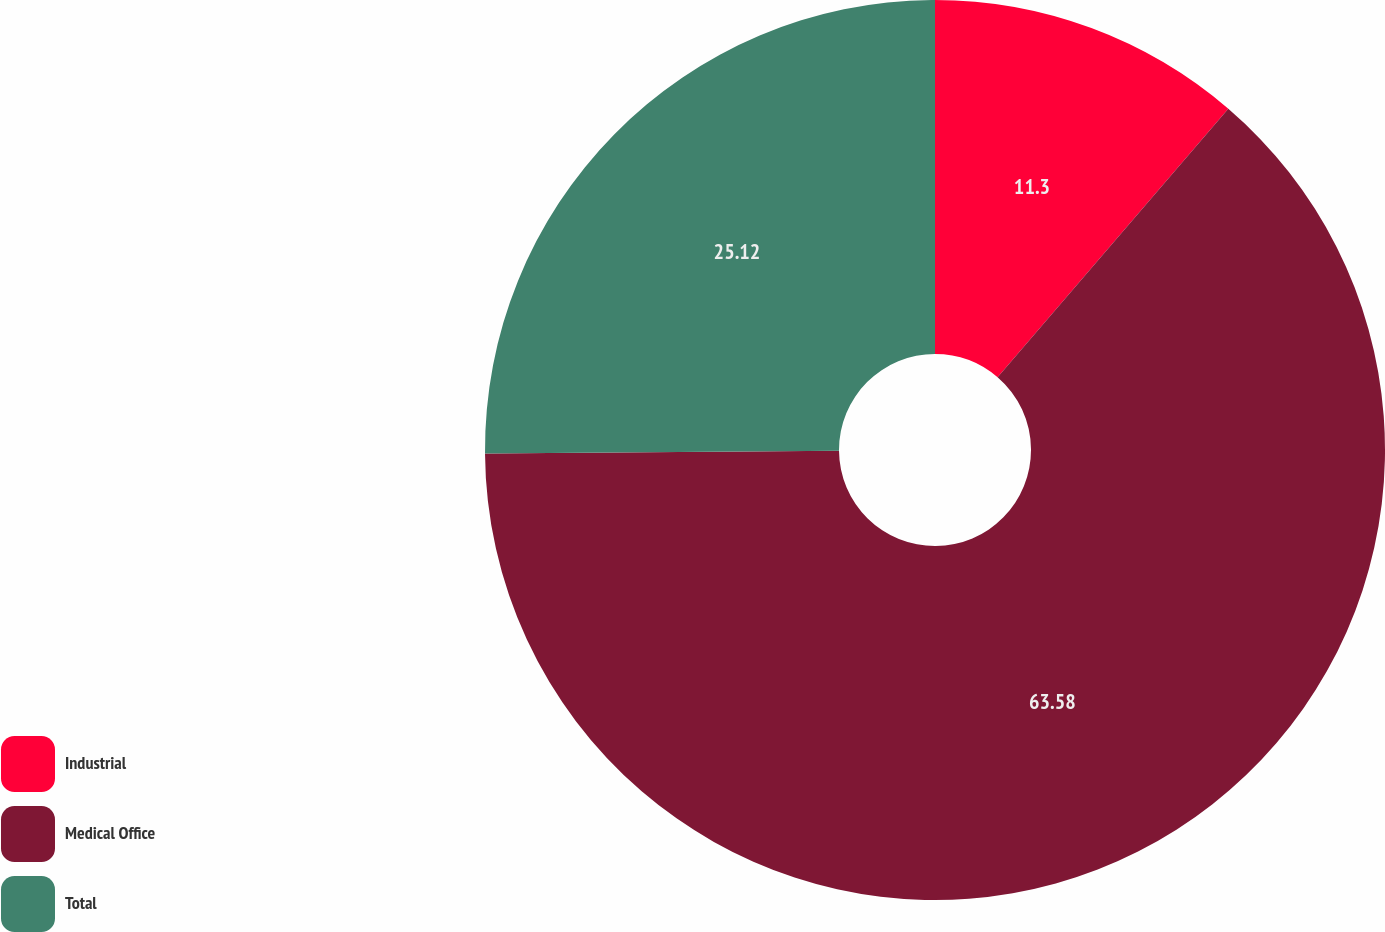Convert chart to OTSL. <chart><loc_0><loc_0><loc_500><loc_500><pie_chart><fcel>Industrial<fcel>Medical Office<fcel>Total<nl><fcel>11.3%<fcel>63.58%<fcel>25.12%<nl></chart> 